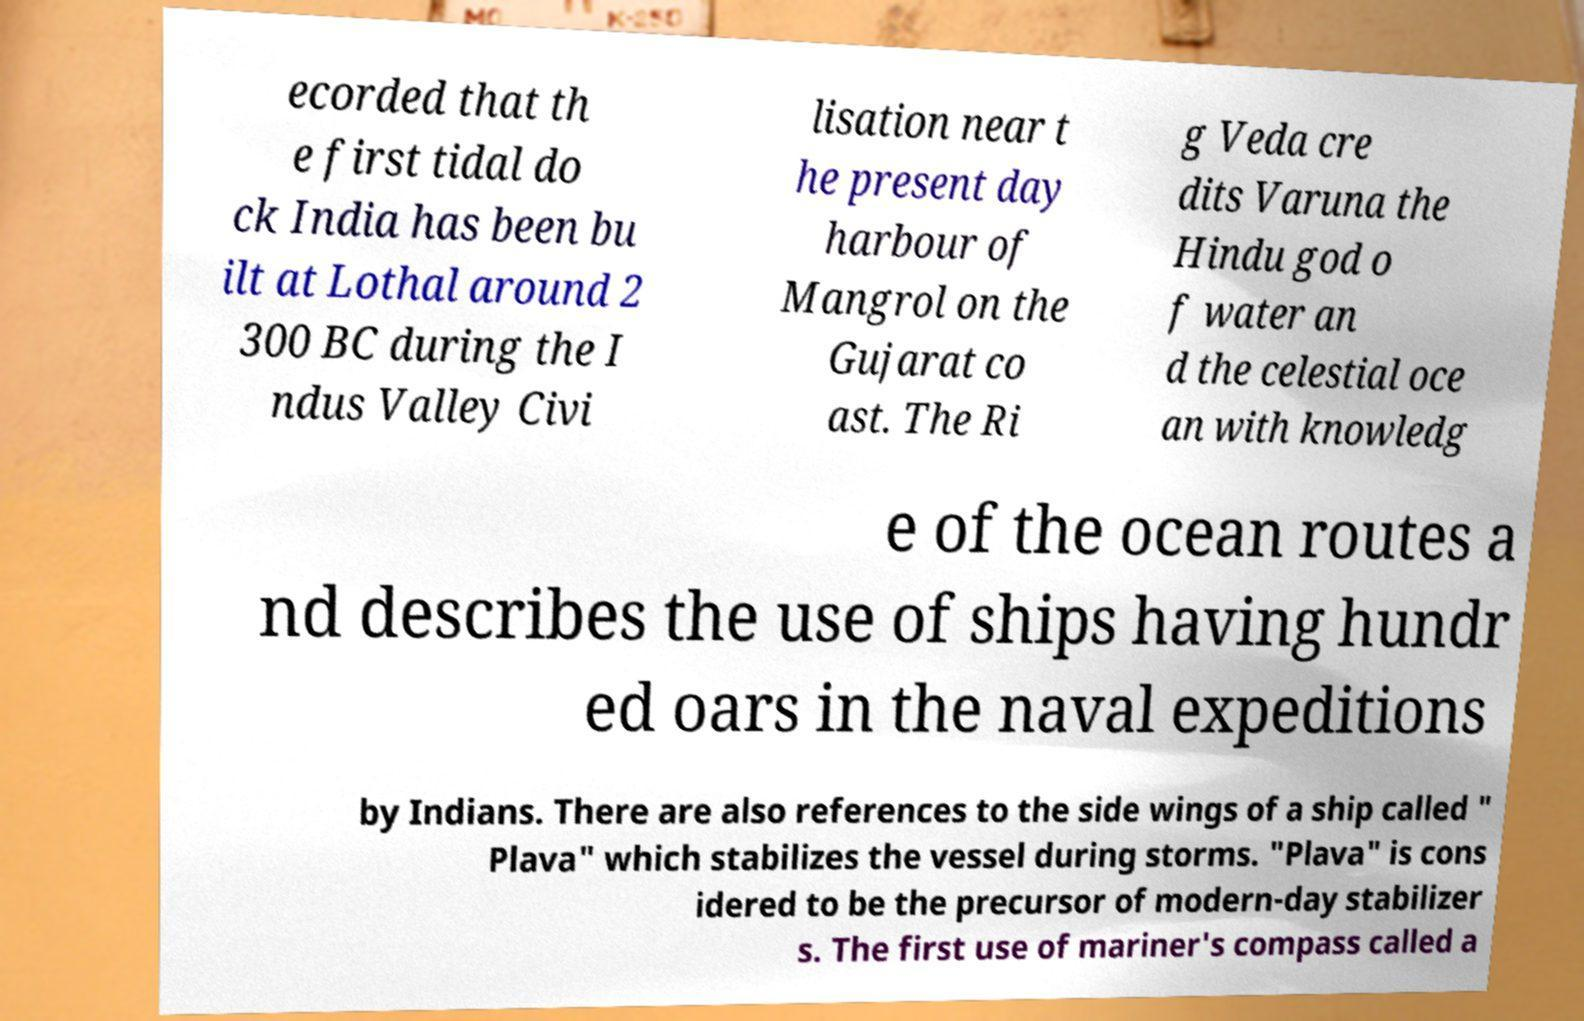Can you accurately transcribe the text from the provided image for me? ecorded that th e first tidal do ck India has been bu ilt at Lothal around 2 300 BC during the I ndus Valley Civi lisation near t he present day harbour of Mangrol on the Gujarat co ast. The Ri g Veda cre dits Varuna the Hindu god o f water an d the celestial oce an with knowledg e of the ocean routes a nd describes the use of ships having hundr ed oars in the naval expeditions by Indians. There are also references to the side wings of a ship called " Plava" which stabilizes the vessel during storms. "Plava" is cons idered to be the precursor of modern-day stabilizer s. The first use of mariner's compass called a 